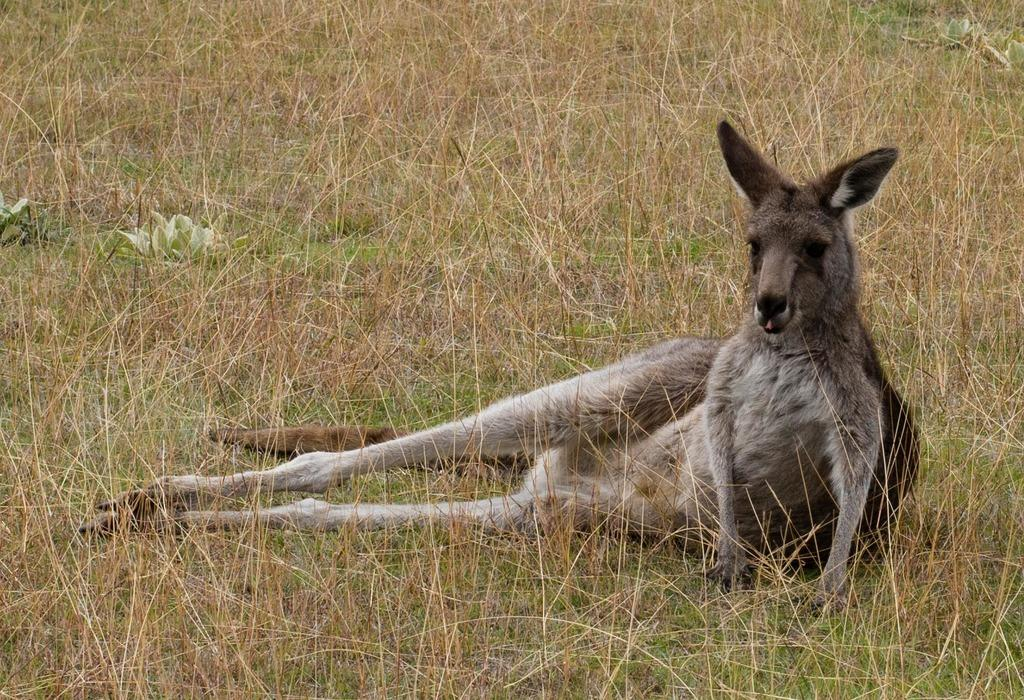What type of animal is in the image? The type of animal cannot be determined from the provided facts. What is the animal standing on in the image? The animal is standing on grass in the image. How much profit does the animal make in the image? There is no indication of profit or any financial activity in the image, as it features an animal and grass. 